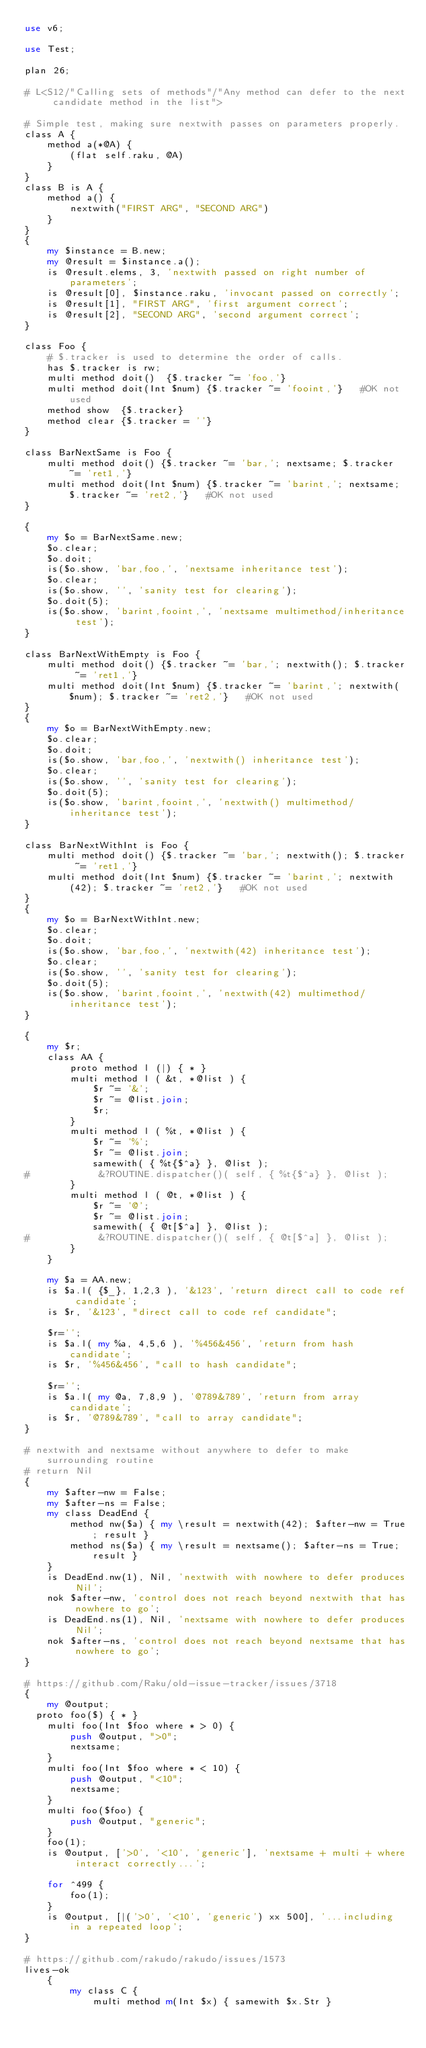Convert code to text. <code><loc_0><loc_0><loc_500><loc_500><_Perl_>use v6;

use Test;

plan 26;

# L<S12/"Calling sets of methods"/"Any method can defer to the next candidate method in the list">

# Simple test, making sure nextwith passes on parameters properly.
class A {
    method a(*@A) {
        (flat self.raku, @A)
    }
}
class B is A {
    method a() {
        nextwith("FIRST ARG", "SECOND ARG")
    }
}
{
    my $instance = B.new;
    my @result = $instance.a();
    is @result.elems, 3, 'nextwith passed on right number of parameters';
    is @result[0], $instance.raku, 'invocant passed on correctly';
    is @result[1], "FIRST ARG", 'first argument correct';
    is @result[2], "SECOND ARG", 'second argument correct';
}

class Foo {
    # $.tracker is used to determine the order of calls.
    has $.tracker is rw;
    multi method doit()  {$.tracker ~= 'foo,'}
    multi method doit(Int $num) {$.tracker ~= 'fooint,'}   #OK not used
    method show  {$.tracker}
    method clear {$.tracker = ''}
}

class BarNextSame is Foo {
    multi method doit() {$.tracker ~= 'bar,'; nextsame; $.tracker ~= 'ret1,'}
    multi method doit(Int $num) {$.tracker ~= 'barint,'; nextsame; $.tracker ~= 'ret2,'}   #OK not used
}

{
    my $o = BarNextSame.new;
    $o.clear;
    $o.doit;
    is($o.show, 'bar,foo,', 'nextsame inheritance test');
    $o.clear;
    is($o.show, '', 'sanity test for clearing');
    $o.doit(5);
    is($o.show, 'barint,fooint,', 'nextsame multimethod/inheritance test');
}

class BarNextWithEmpty is Foo {
    multi method doit() {$.tracker ~= 'bar,'; nextwith(); $.tracker ~= 'ret1,'}
    multi method doit(Int $num) {$.tracker ~= 'barint,'; nextwith($num); $.tracker ~= 'ret2,'}   #OK not used
}
{
    my $o = BarNextWithEmpty.new;
    $o.clear;
    $o.doit;
    is($o.show, 'bar,foo,', 'nextwith() inheritance test');
    $o.clear;
    is($o.show, '', 'sanity test for clearing');
    $o.doit(5);
    is($o.show, 'barint,fooint,', 'nextwith() multimethod/inheritance test');
}

class BarNextWithInt is Foo {
    multi method doit() {$.tracker ~= 'bar,'; nextwith(); $.tracker ~= 'ret1,'}
    multi method doit(Int $num) {$.tracker ~= 'barint,'; nextwith(42); $.tracker ~= 'ret2,'}   #OK not used
}
{
    my $o = BarNextWithInt.new;
    $o.clear;
    $o.doit;
    is($o.show, 'bar,foo,', 'nextwith(42) inheritance test');
    $o.clear;
    is($o.show, '', 'sanity test for clearing');
    $o.doit(5);
    is($o.show, 'barint,fooint,', 'nextwith(42) multimethod/inheritance test');
}

{
    my $r;
    class AA {
        proto method l (|) { * }
        multi method l ( &t, *@list ) {
            $r ~= '&';
            $r ~= @list.join;
            $r;
        }
        multi method l ( %t, *@list ) {
            $r ~= '%';
            $r ~= @list.join;
            samewith( { %t{$^a} }, @list );
#            &?ROUTINE.dispatcher()( self, { %t{$^a} }, @list );
        }
        multi method l ( @t, *@list ) {
            $r ~= '@';
            $r ~= @list.join;
            samewith( { @t[$^a] }, @list );
#            &?ROUTINE.dispatcher()( self, { @t[$^a] }, @list );
        }
    }

    my $a = AA.new;
    is $a.l( {$_}, 1,2,3 ), '&123', 'return direct call to code ref candidate';
    is $r, '&123', "direct call to code ref candidate";

    $r='';
    is $a.l( my %a, 4,5,6 ), '%456&456', 'return from hash candidate';
    is $r, '%456&456', "call to hash candidate";

    $r='';
    is $a.l( my @a, 7,8,9 ), '@789&789', 'return from array candidate';
    is $r, '@789&789', "call to array candidate";
}

# nextwith and nextsame without anywhere to defer to make surrounding routine
# return Nil
{
    my $after-nw = False;
    my $after-ns = False;
    my class DeadEnd {
        method nw($a) { my \result = nextwith(42); $after-nw = True; result }
        method ns($a) { my \result = nextsame(); $after-ns = True; result }
    }
    is DeadEnd.nw(1), Nil, 'nextwith with nowhere to defer produces Nil';
    nok $after-nw, 'control does not reach beyond nextwith that has nowhere to go';
    is DeadEnd.ns(1), Nil, 'nextsame with nowhere to defer produces Nil';
    nok $after-ns, 'control does not reach beyond nextsame that has nowhere to go';
}

# https://github.com/Raku/old-issue-tracker/issues/3718
{
    my @output;
	proto foo($) { * }
    multi foo(Int $foo where * > 0) {
        push @output, ">0";
        nextsame;
    }
    multi foo(Int $foo where * < 10) {
        push @output, "<10";
        nextsame;
    }
    multi foo($foo) {
        push @output, "generic";
    }
    foo(1);
    is @output, ['>0', '<10', 'generic'], 'nextsame + multi + where interact correctly...';

    for ^499 {
        foo(1);
    }
    is @output, [|('>0', '<10', 'generic') xx 500], '...including in a repeated loop';
}

# https://github.com/rakudo/rakudo/issues/1573
lives-ok
    {
        my class C {
            multi method m(Int $x) { samewith $x.Str }</code> 